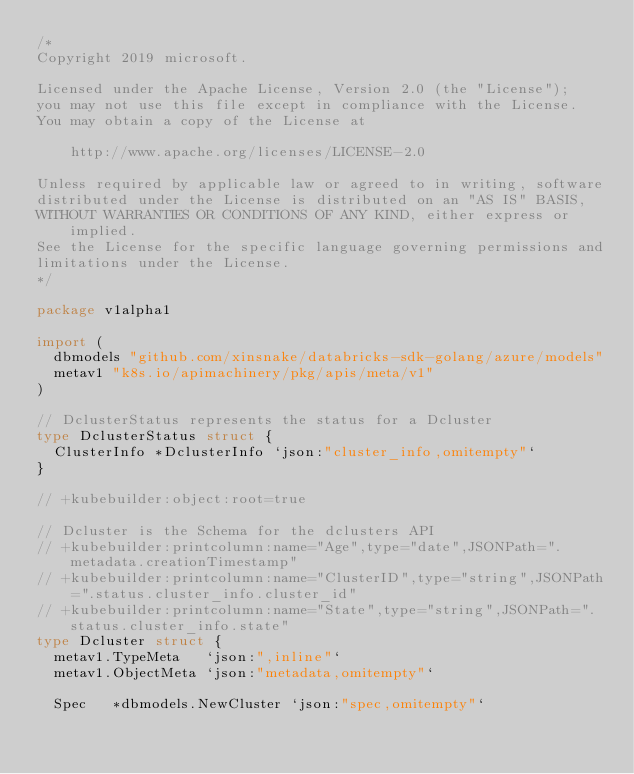Convert code to text. <code><loc_0><loc_0><loc_500><loc_500><_Go_>/*
Copyright 2019 microsoft.

Licensed under the Apache License, Version 2.0 (the "License");
you may not use this file except in compliance with the License.
You may obtain a copy of the License at

    http://www.apache.org/licenses/LICENSE-2.0

Unless required by applicable law or agreed to in writing, software
distributed under the License is distributed on an "AS IS" BASIS,
WITHOUT WARRANTIES OR CONDITIONS OF ANY KIND, either express or implied.
See the License for the specific language governing permissions and
limitations under the License.
*/

package v1alpha1

import (
	dbmodels "github.com/xinsnake/databricks-sdk-golang/azure/models"
	metav1 "k8s.io/apimachinery/pkg/apis/meta/v1"
)

// DclusterStatus represents the status for a Dcluster
type DclusterStatus struct {
	ClusterInfo *DclusterInfo `json:"cluster_info,omitempty"`
}

// +kubebuilder:object:root=true

// Dcluster is the Schema for the dclusters API
// +kubebuilder:printcolumn:name="Age",type="date",JSONPath=".metadata.creationTimestamp"
// +kubebuilder:printcolumn:name="ClusterID",type="string",JSONPath=".status.cluster_info.cluster_id"
// +kubebuilder:printcolumn:name="State",type="string",JSONPath=".status.cluster_info.state"
type Dcluster struct {
	metav1.TypeMeta   `json:",inline"`
	metav1.ObjectMeta `json:"metadata,omitempty"`

	Spec   *dbmodels.NewCluster `json:"spec,omitempty"`</code> 